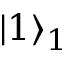Convert formula to latex. <formula><loc_0><loc_0><loc_500><loc_500>\left | 1 \right \rangle _ { 1 }</formula> 